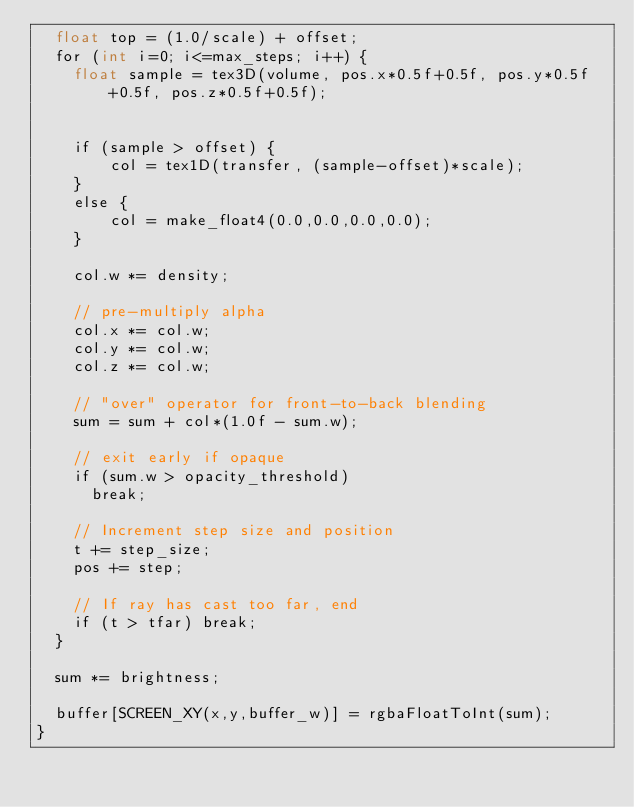<code> <loc_0><loc_0><loc_500><loc_500><_Cuda_>  float top = (1.0/scale) + offset;
  for (int i=0; i<=max_steps; i++) {
    float sample = tex3D(volume, pos.x*0.5f+0.5f, pos.y*0.5f+0.5f, pos.z*0.5f+0.5f);
    

    if (sample > offset) {
        col = tex1D(transfer, (sample-offset)*scale);
    }
    else {
        col = make_float4(0.0,0.0,0.0,0.0);
    }

    col.w *= density;

    // pre-multiply alpha
    col.x *= col.w;
    col.y *= col.w;
    col.z *= col.w;

    // "over" operator for front-to-back blending
    sum = sum + col*(1.0f - sum.w);

    // exit early if opaque
    if (sum.w > opacity_threshold)
      break;

    // Increment step size and position
    t += step_size;
    pos += step;

    // If ray has cast too far, end
    if (t > tfar) break;
  }

  sum *= brightness;

  buffer[SCREEN_XY(x,y,buffer_w)] = rgbaFloatToInt(sum);
}

</code> 